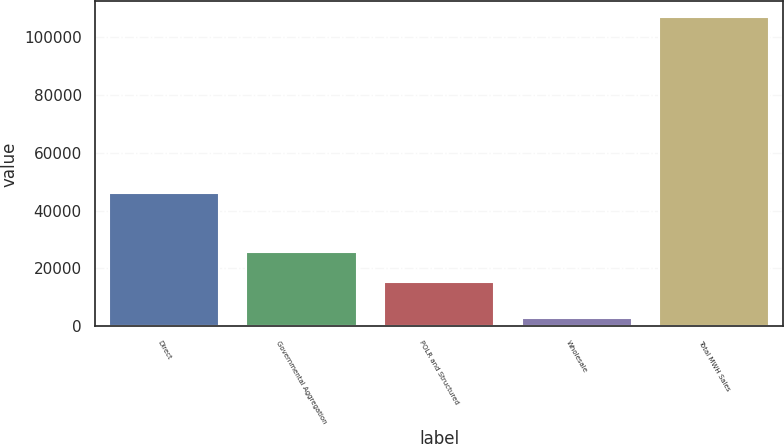Convert chart. <chart><loc_0><loc_0><loc_500><loc_500><bar_chart><fcel>Direct<fcel>Governmental Aggregation<fcel>POLR and Structured<fcel>Wholesale<fcel>Total MWH Sales<nl><fcel>46187<fcel>25738.1<fcel>15340<fcel>2916<fcel>106897<nl></chart> 